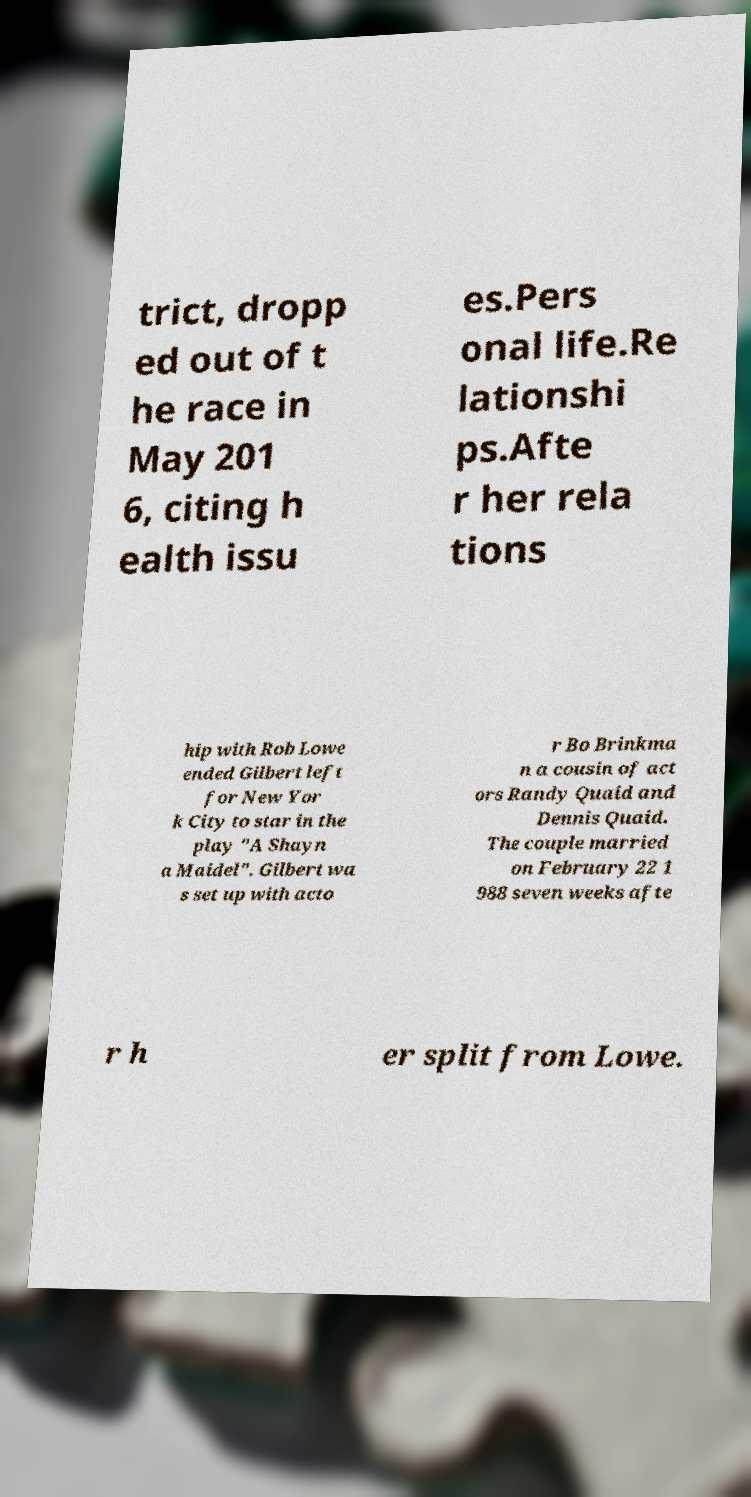I need the written content from this picture converted into text. Can you do that? trict, dropp ed out of t he race in May 201 6, citing h ealth issu es.Pers onal life.Re lationshi ps.Afte r her rela tions hip with Rob Lowe ended Gilbert left for New Yor k City to star in the play "A Shayn a Maidel". Gilbert wa s set up with acto r Bo Brinkma n a cousin of act ors Randy Quaid and Dennis Quaid. The couple married on February 22 1 988 seven weeks afte r h er split from Lowe. 